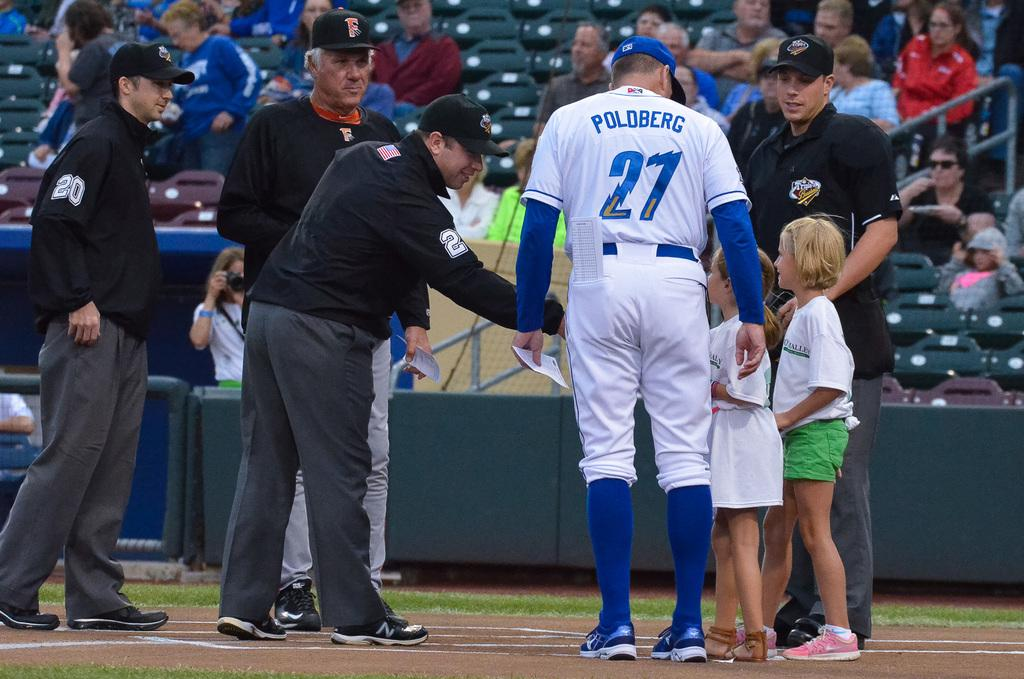<image>
Describe the image concisely. Two children are on the baseball field meeting umpires and player number 27. 